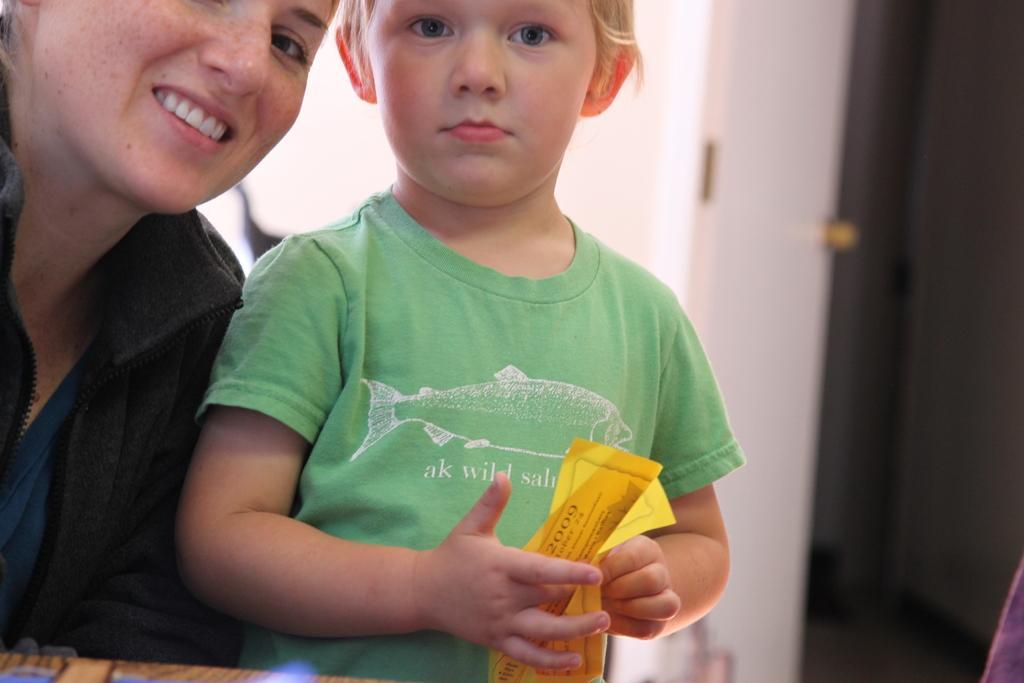Describe this image in one or two sentences. In this image I can see two persons wearing black and green colored dresses and a person is holding a yellow colored paper in his hand. I can see the white and black colored background in which I can see the wall and the door. 